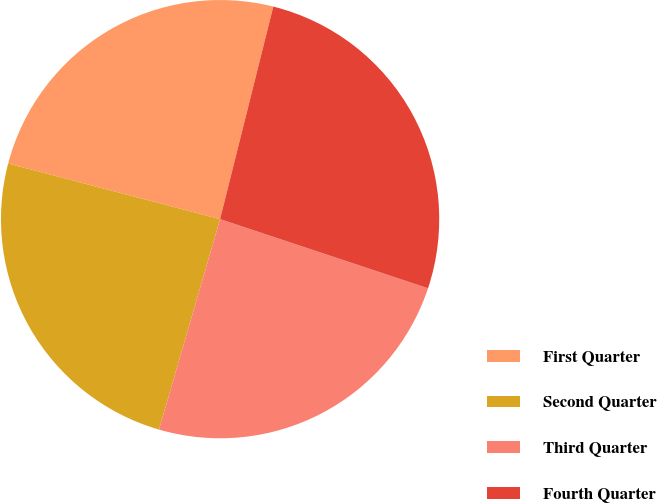Convert chart. <chart><loc_0><loc_0><loc_500><loc_500><pie_chart><fcel>First Quarter<fcel>Second Quarter<fcel>Third Quarter<fcel>Fourth Quarter<nl><fcel>24.82%<fcel>24.58%<fcel>24.39%<fcel>26.2%<nl></chart> 